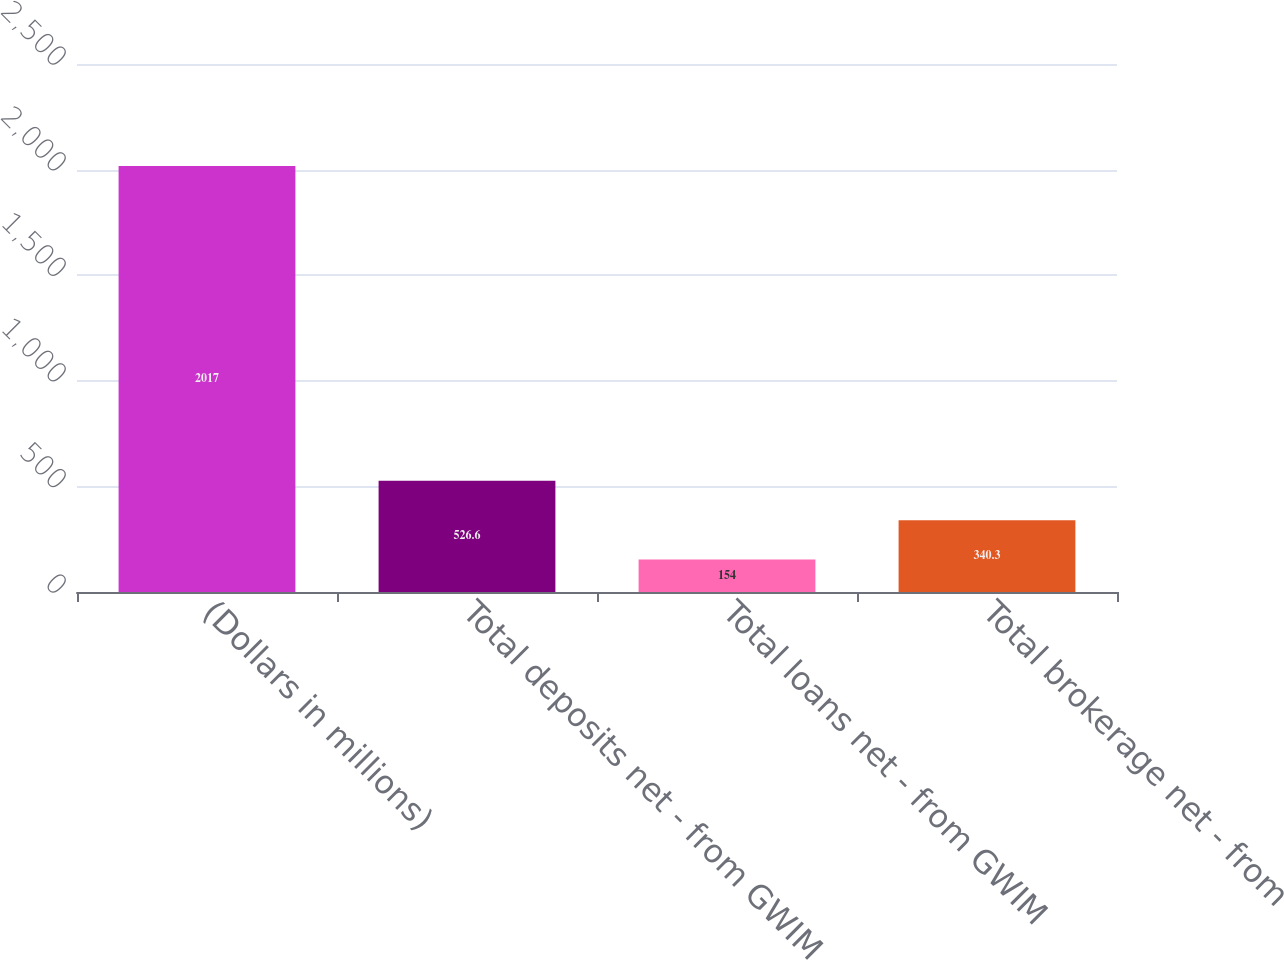Convert chart to OTSL. <chart><loc_0><loc_0><loc_500><loc_500><bar_chart><fcel>(Dollars in millions)<fcel>Total deposits net - from GWIM<fcel>Total loans net - from GWIM<fcel>Total brokerage net - from<nl><fcel>2017<fcel>526.6<fcel>154<fcel>340.3<nl></chart> 